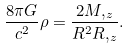<formula> <loc_0><loc_0><loc_500><loc_500>\frac { 8 \pi G } { c ^ { 2 } } \rho = \frac { 2 M , _ { z } } { R ^ { 2 } R , _ { z } } .</formula> 